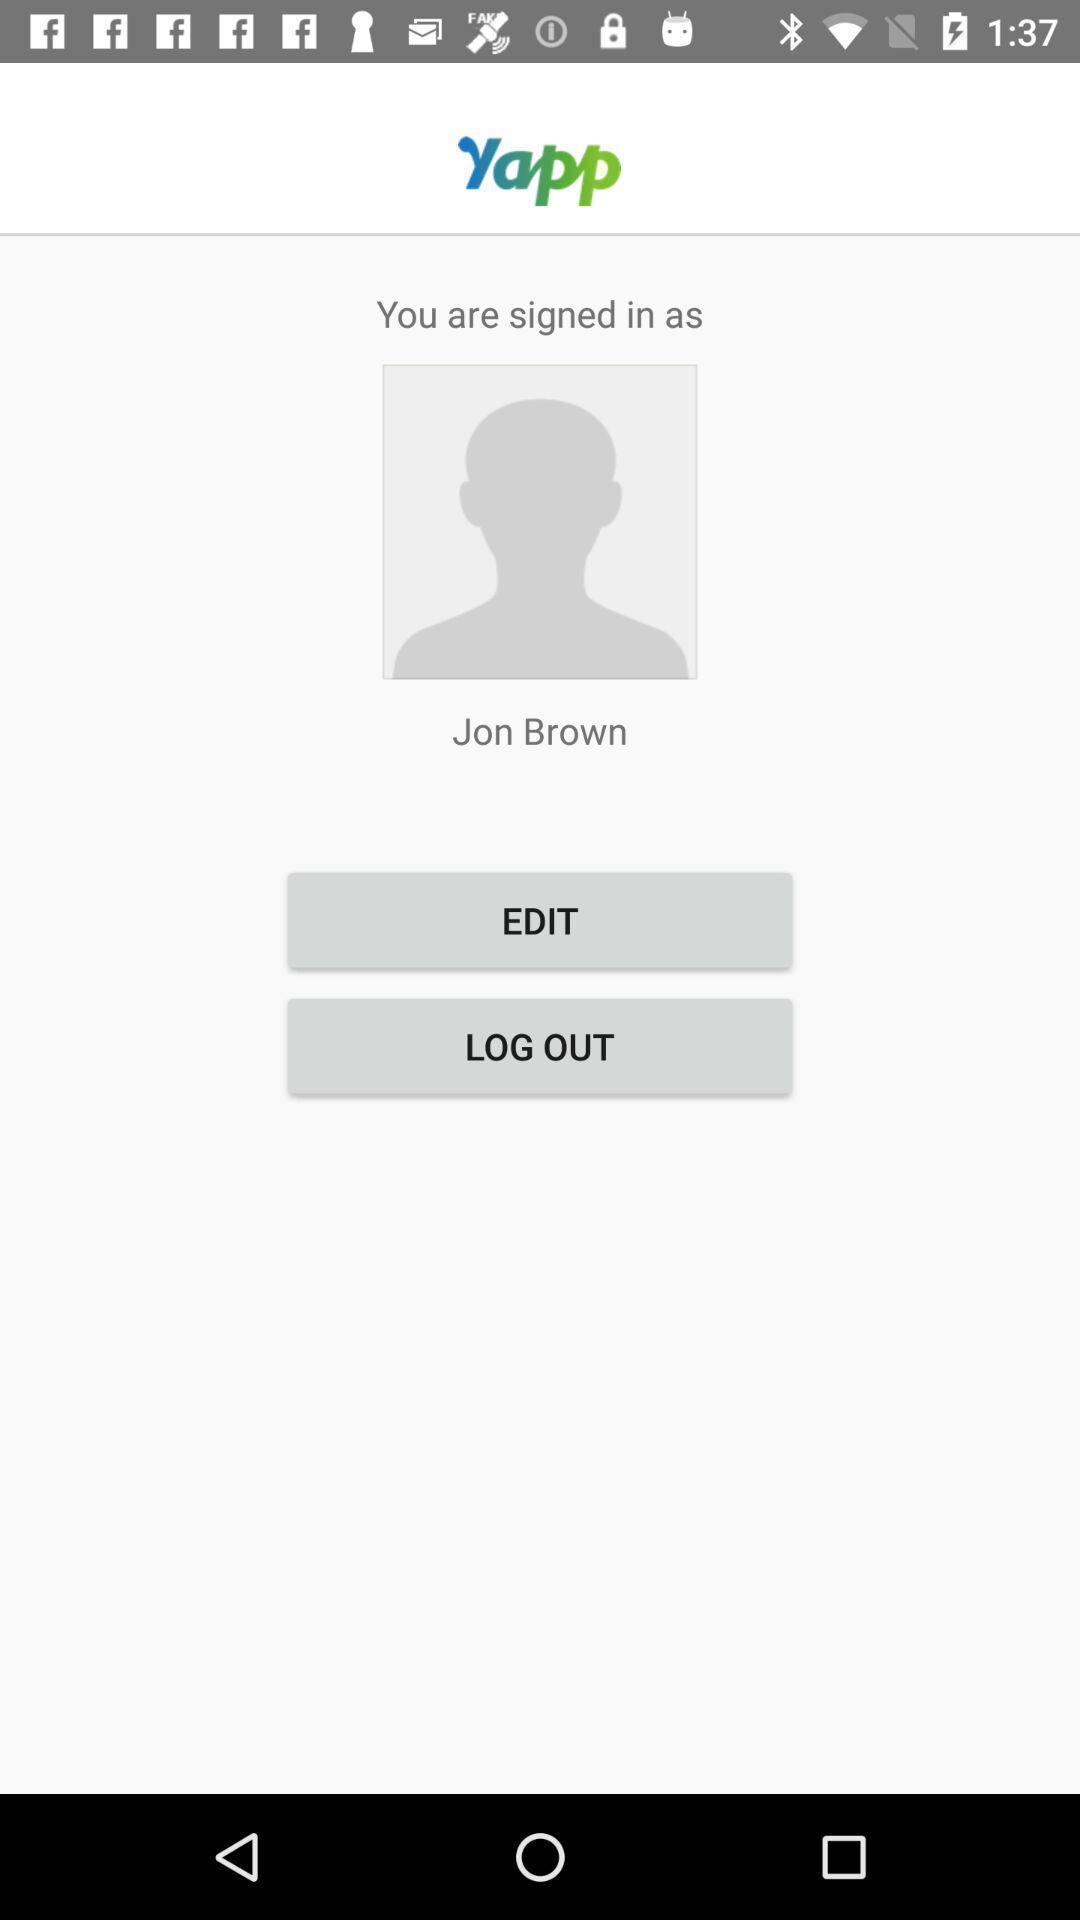Describe the visual elements of this screenshot. Profile page in a social networking app. 